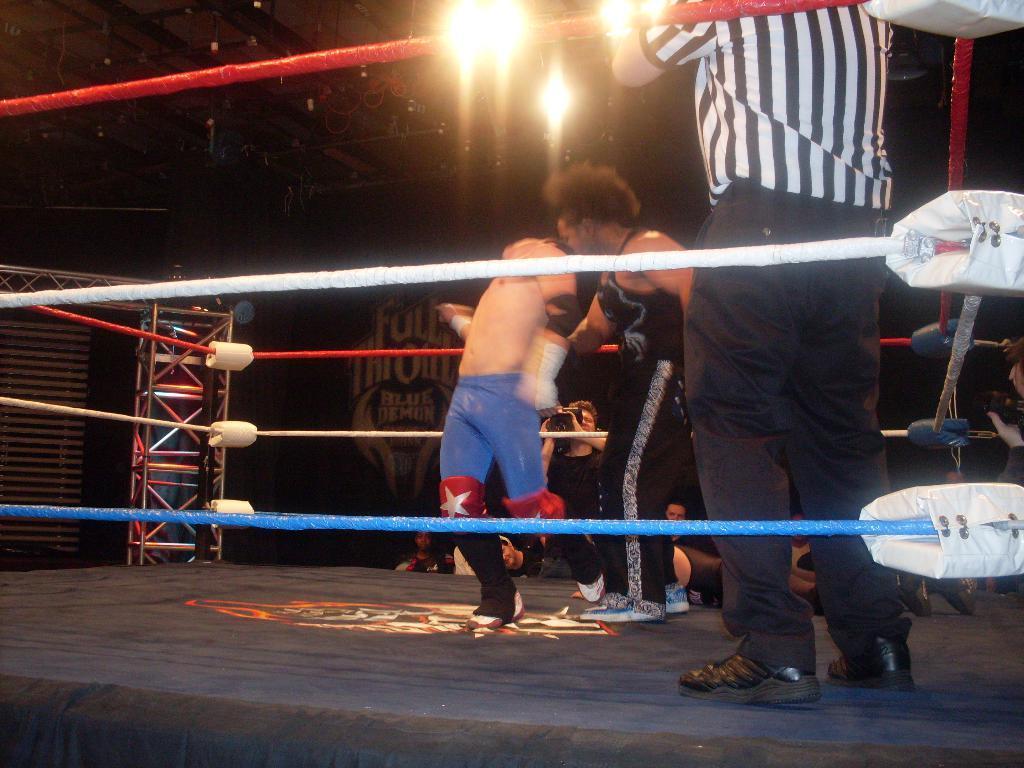How would you summarize this image in a sentence or two? At the top we can see the lights and its dark. In this picture we can see men on the platform. We can see both men fighting. Far we can see people and a man is holding a camera and recording. Far we can see hoarding, stand and wooden poles, it seems like a window blind. We can see colorful ropes around the platform with some white objects. 